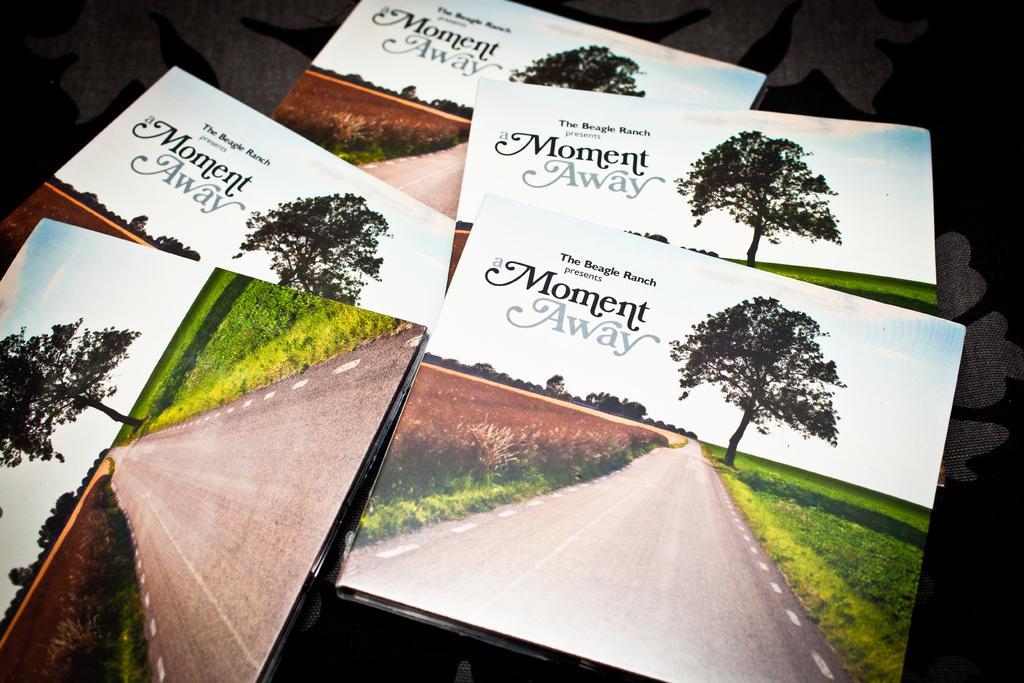How would you summarize this image in a sentence or two? We can see books on the surface,on these books same picture,we can see tree,road and grass. 